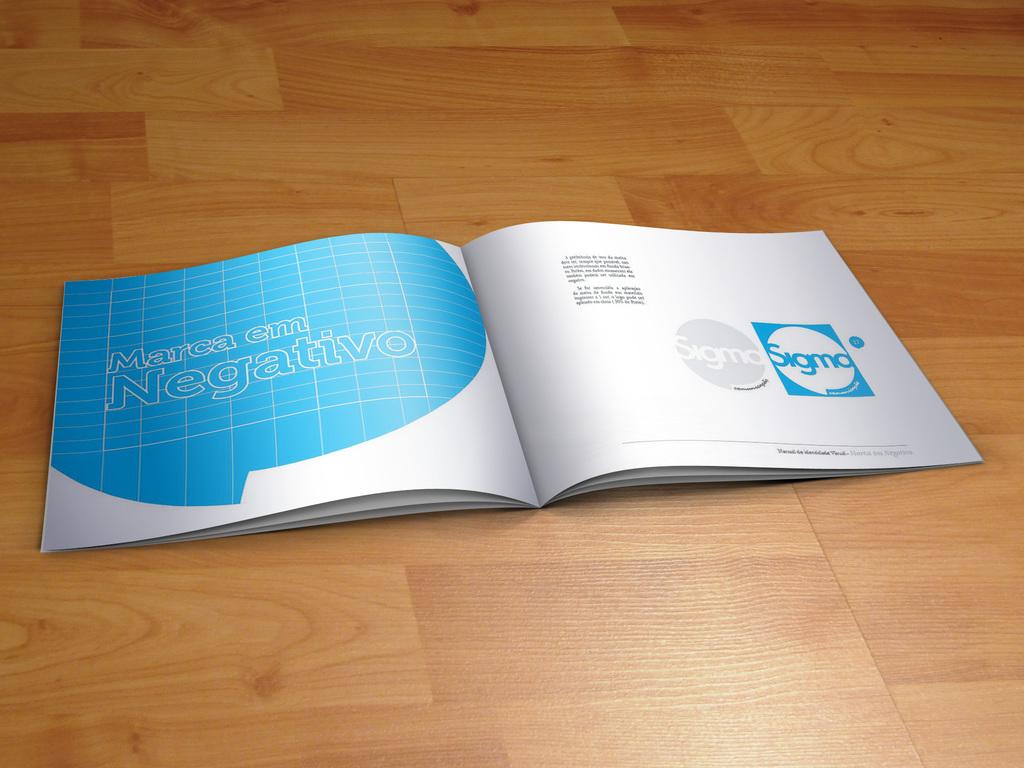What does the text on the left page say?
Keep it short and to the point. Marca em negativo. Is this a paper book?
Your response must be concise. Answering does not require reading text in the image. 